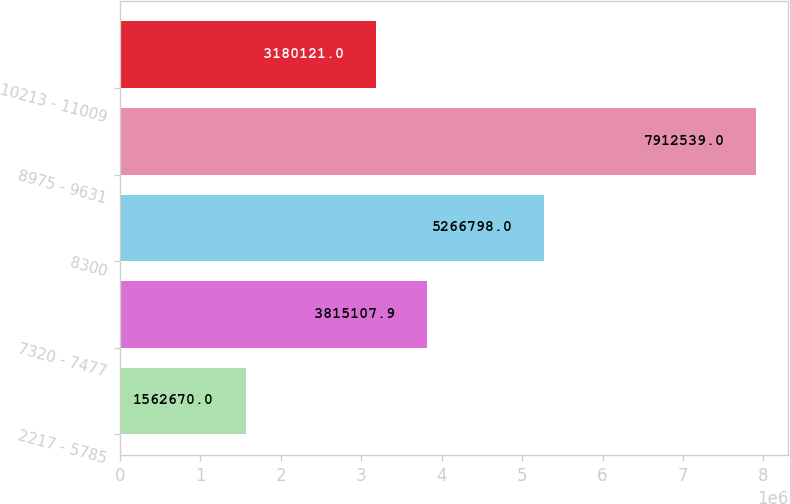Convert chart. <chart><loc_0><loc_0><loc_500><loc_500><bar_chart><fcel>2217 - 5785<fcel>7320 - 7477<fcel>8300<fcel>8975 - 9631<fcel>10213 - 11009<nl><fcel>1.56267e+06<fcel>3.81511e+06<fcel>5.2668e+06<fcel>7.91254e+06<fcel>3.18012e+06<nl></chart> 